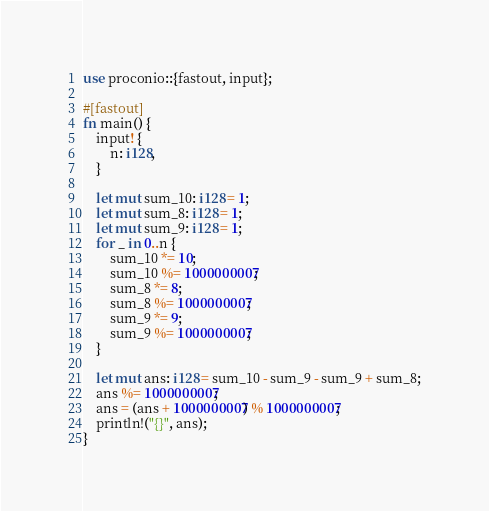Convert code to text. <code><loc_0><loc_0><loc_500><loc_500><_Rust_>use proconio::{fastout, input};

#[fastout]
fn main() {
    input! {
        n: i128,
    }

    let mut sum_10: i128 = 1;
    let mut sum_8: i128 = 1;
    let mut sum_9: i128 = 1;
    for _ in 0..n {
        sum_10 *= 10;
        sum_10 %= 1000000007;
        sum_8 *= 8;
        sum_8 %= 1000000007;
        sum_9 *= 9;
        sum_9 %= 1000000007;
    }

    let mut ans: i128 = sum_10 - sum_9 - sum_9 + sum_8;
    ans %= 1000000007;
    ans = (ans + 1000000007) % 1000000007;
    println!("{}", ans);
}
</code> 